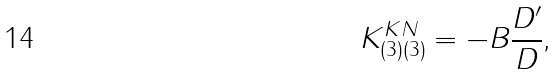Convert formula to latex. <formula><loc_0><loc_0><loc_500><loc_500>K _ { ( 3 ) ( 3 ) } ^ { K N } = - B \frac { D ^ { \prime } } { D } \text {,}</formula> 